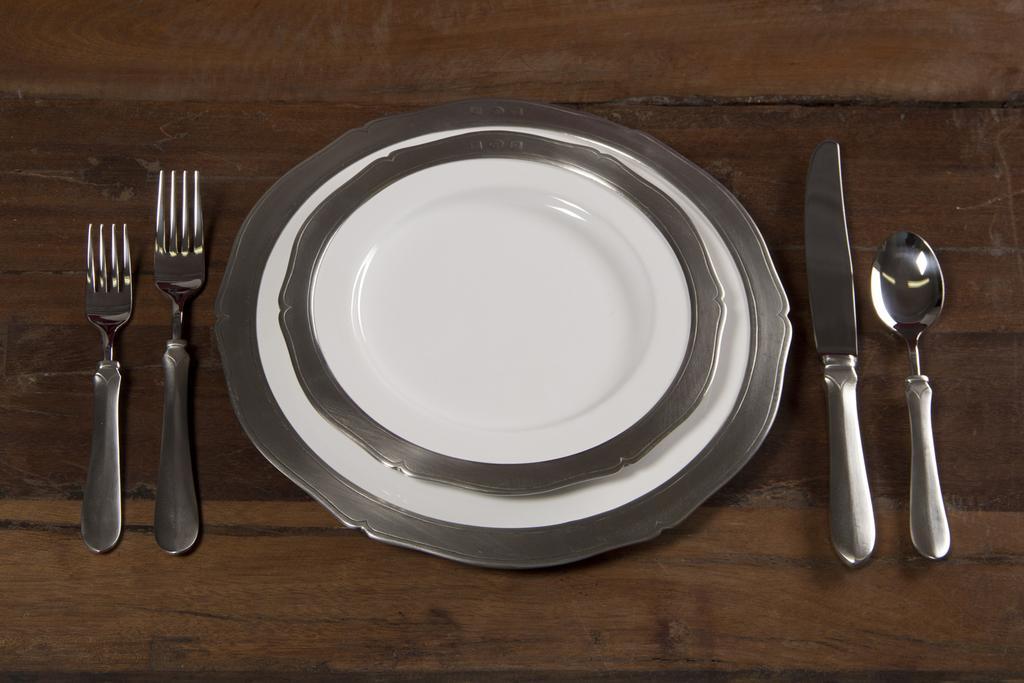In one or two sentences, can you explain what this image depicts? In this picture I can observe two plates placed on the wooden surface. I can observe two forks, knife and a spoon on the wooden surface. 